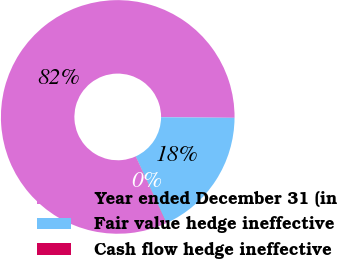Convert chart. <chart><loc_0><loc_0><loc_500><loc_500><pie_chart><fcel>Year ended December 31 (in<fcel>Fair value hedge ineffective<fcel>Cash flow hedge ineffective<nl><fcel>81.91%<fcel>18.04%<fcel>0.04%<nl></chart> 